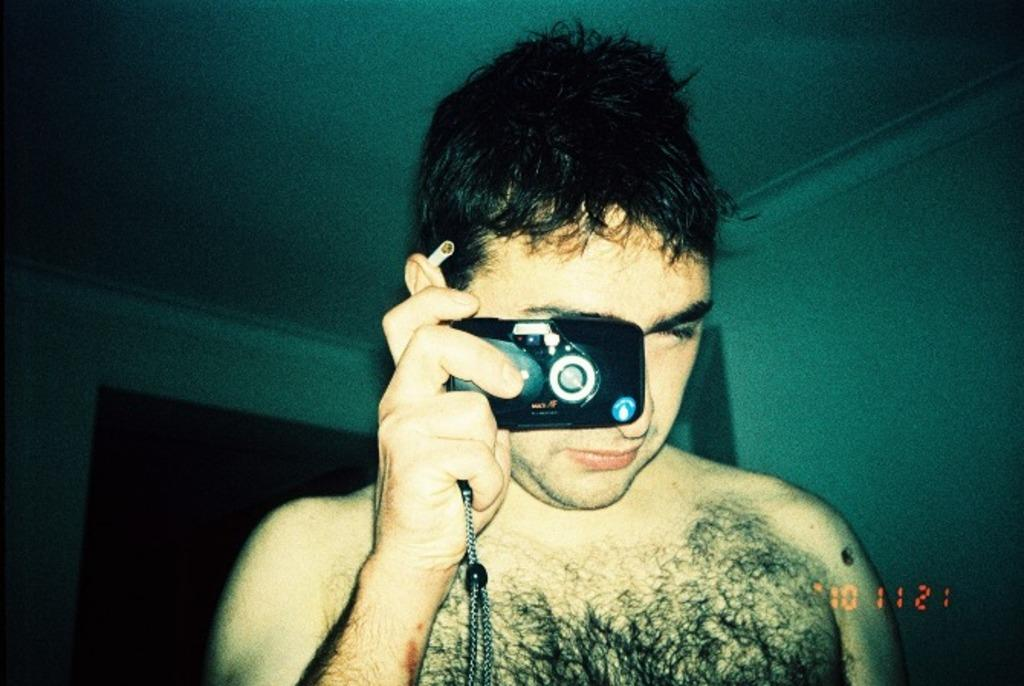Who is the main subject in the image? There is a man in the center of the image. What is the man holding in the image? The man is holding a camera. What can be seen in the background of the image? There is a wall in the background of the image. What grade is the man teaching in the image? There is no indication in the image that the man is teaching, nor is there any reference to a grade. 